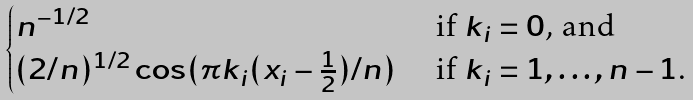Convert formula to latex. <formula><loc_0><loc_0><loc_500><loc_500>\begin{cases} n ^ { - 1 / 2 } & \text { if $k_{i}=0$, and} \\ ( 2 / n ) ^ { 1 / 2 } \cos ( \pi k _ { i } ( x _ { i } - \frac { 1 } { 2 } ) / n ) & \text { if $k_{i}=1,\dots,n-1$.} \end{cases}</formula> 